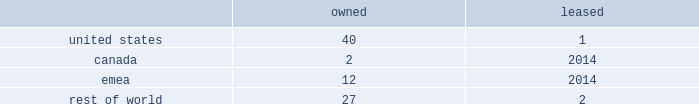Volatility of capital markets or macroeconomic factors could adversely affect our business .
Changes in financial and capital markets , including market disruptions , limited liquidity , uncertainty regarding brexit , and interest rate volatility , including as a result of the use or discontinued use of certain benchmark rates such as libor , may increase the cost of financing as well as the risks of refinancing maturing debt .
In addition , our borrowing costs can be affected by short and long-term ratings assigned by rating organizations .
A decrease in these ratings could limit our access to capital markets and increase our borrowing costs , which could materially and adversely affect our financial condition and operating results .
Some of our customers and counterparties are highly leveraged .
Consolidations in some of the industries in which our customers operate have created larger customers , some of which are highly leveraged and facing increased competition and continued credit market volatility .
These factors have caused some customers to be less profitable , increasing our exposure to credit risk .
A significant adverse change in the financial and/or credit position of a customer or counterparty could require us to assume greater credit risk relating to that customer or counterparty and could limit our ability to collect receivables .
This could have an adverse impact on our financial condition and liquidity .
Item 1b .
Unresolved staff comments .
Item 2 .
Properties .
Our corporate co-headquarters are located in pittsburgh , pennsylvania and chicago , illinois .
Our co-headquarters are leased and house certain executive offices , our u.s .
Business units , and our administrative , finance , legal , and human resource functions .
We maintain additional owned and leased offices throughout the regions in which we operate .
We manufacture our products in our network of manufacturing and processing facilities located throughout the world .
As of december 29 , 2018 , we operated 84 manufacturing and processing facilities .
We own 81 and lease three of these facilities .
Our manufacturing and processing facilities count by segment as of december 29 , 2018 was: .
We maintain all of our manufacturing and processing facilities in good condition and believe they are suitable and are adequate for our present needs .
We also enter into co-manufacturing arrangements with third parties if we determine it is advantageous to outsource the production of any of our products .
In the fourth quarter of 2018 , we announced our plans to divest certain assets and operations , predominantly in canada and india , including one owned manufacturing facility in canada and one owned and one leased facility in india .
See note 5 , acquisitions and divestitures , in item 8 , financial statements and supplementary data , for additional information on these transactions .
Item 3 .
Legal proceedings .
See note 18 , commitments and contingencies , in item 8 , financial statements and supplementary data .
Item 4 .
Mine safety disclosures .
Not applicable .
Part ii item 5 .
Market for registrant's common equity , related stockholder matters and issuer purchases of equity securities .
Our common stock is listed on nasdaq under the ticker symbol 201ckhc 201d .
At june 5 , 2019 , there were approximately 49000 holders of record of our common stock .
See equity and dividends in item 7 , management 2019s discussion and analysis of financial condition and results of operations , for a discussion of cash dividends declared on our common stock. .
What is the portion of total number of facilities located in the united states? 
Computations: ((40 + 1) / 84)
Answer: 0.4881. 